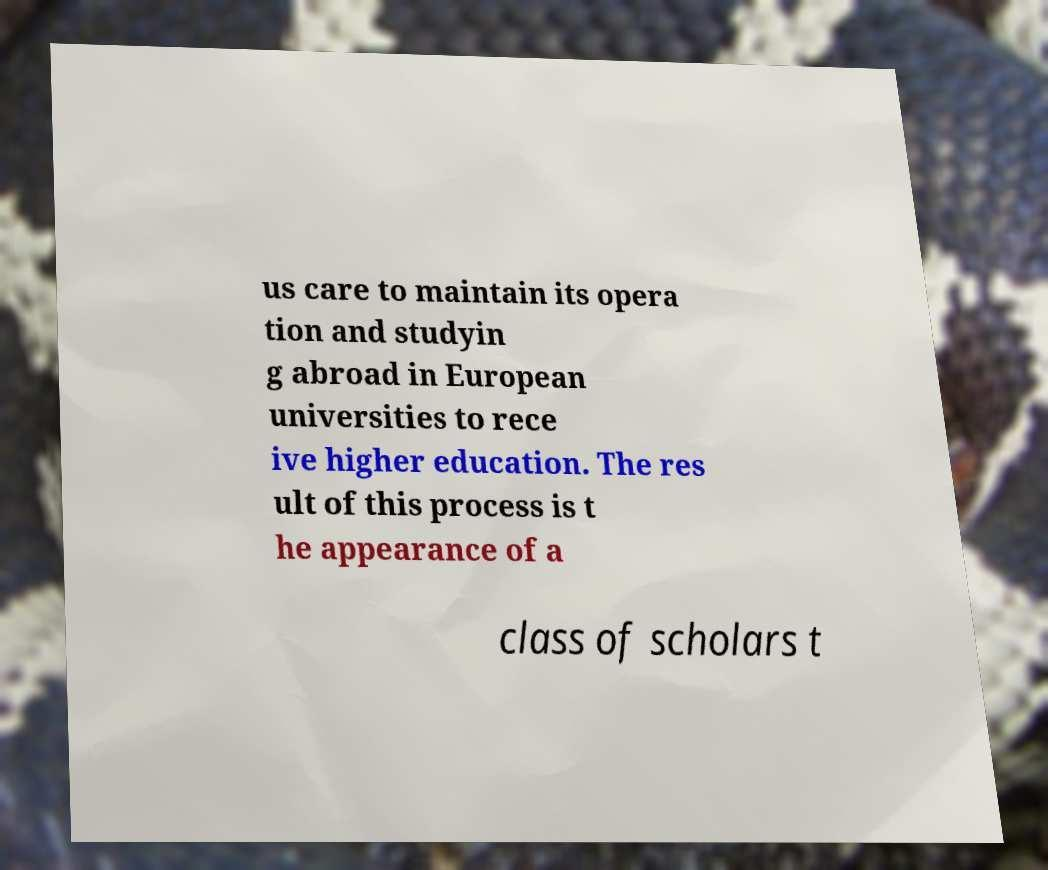Please identify and transcribe the text found in this image. us care to maintain its opera tion and studyin g abroad in European universities to rece ive higher education. The res ult of this process is t he appearance of a class of scholars t 